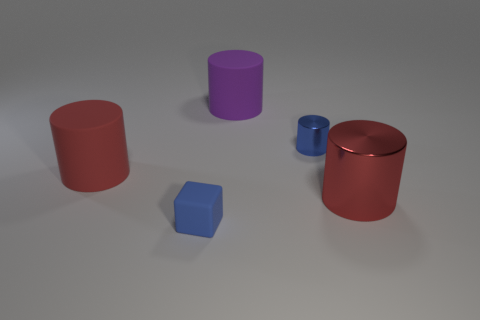Subtract all gray cubes. How many red cylinders are left? 2 Subtract all big cylinders. How many cylinders are left? 1 Subtract 2 cylinders. How many cylinders are left? 2 Subtract all blue cylinders. How many cylinders are left? 3 Add 4 large spheres. How many objects exist? 9 Subtract all gray cylinders. Subtract all blue spheres. How many cylinders are left? 4 Subtract all cubes. How many objects are left? 4 Add 4 purple rubber cylinders. How many purple rubber cylinders exist? 5 Subtract 0 brown cubes. How many objects are left? 5 Subtract all small blue rubber blocks. Subtract all small blue metallic things. How many objects are left? 3 